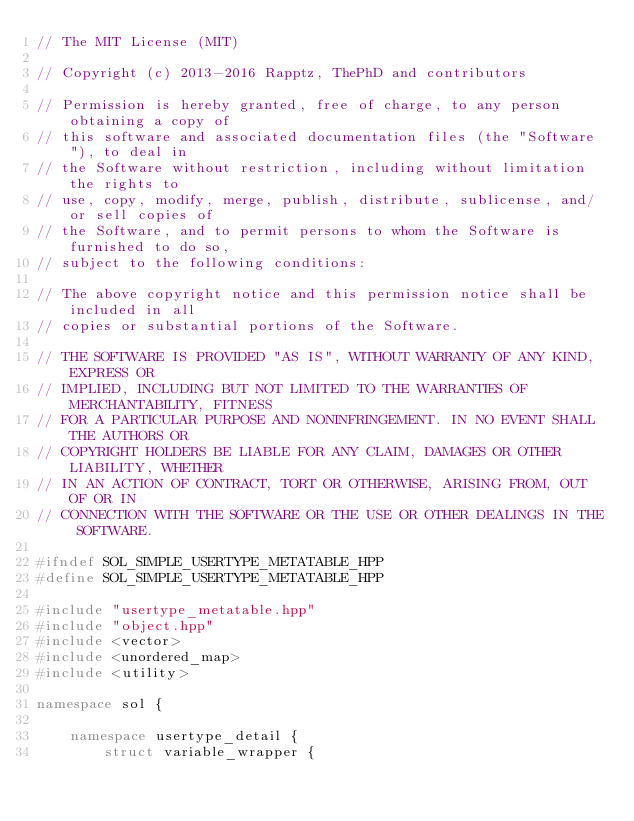Convert code to text. <code><loc_0><loc_0><loc_500><loc_500><_C++_>// The MIT License (MIT) 

// Copyright (c) 2013-2016 Rapptz, ThePhD and contributors

// Permission is hereby granted, free of charge, to any person obtaining a copy of
// this software and associated documentation files (the "Software"), to deal in
// the Software without restriction, including without limitation the rights to
// use, copy, modify, merge, publish, distribute, sublicense, and/or sell copies of
// the Software, and to permit persons to whom the Software is furnished to do so,
// subject to the following conditions:

// The above copyright notice and this permission notice shall be included in all
// copies or substantial portions of the Software.

// THE SOFTWARE IS PROVIDED "AS IS", WITHOUT WARRANTY OF ANY KIND, EXPRESS OR
// IMPLIED, INCLUDING BUT NOT LIMITED TO THE WARRANTIES OF MERCHANTABILITY, FITNESS
// FOR A PARTICULAR PURPOSE AND NONINFRINGEMENT. IN NO EVENT SHALL THE AUTHORS OR
// COPYRIGHT HOLDERS BE LIABLE FOR ANY CLAIM, DAMAGES OR OTHER LIABILITY, WHETHER
// IN AN ACTION OF CONTRACT, TORT OR OTHERWISE, ARISING FROM, OUT OF OR IN
// CONNECTION WITH THE SOFTWARE OR THE USE OR OTHER DEALINGS IN THE SOFTWARE.

#ifndef SOL_SIMPLE_USERTYPE_METATABLE_HPP
#define SOL_SIMPLE_USERTYPE_METATABLE_HPP

#include "usertype_metatable.hpp"
#include "object.hpp"
#include <vector>
#include <unordered_map>
#include <utility>

namespace sol {

	namespace usertype_detail {
		struct variable_wrapper {</code> 